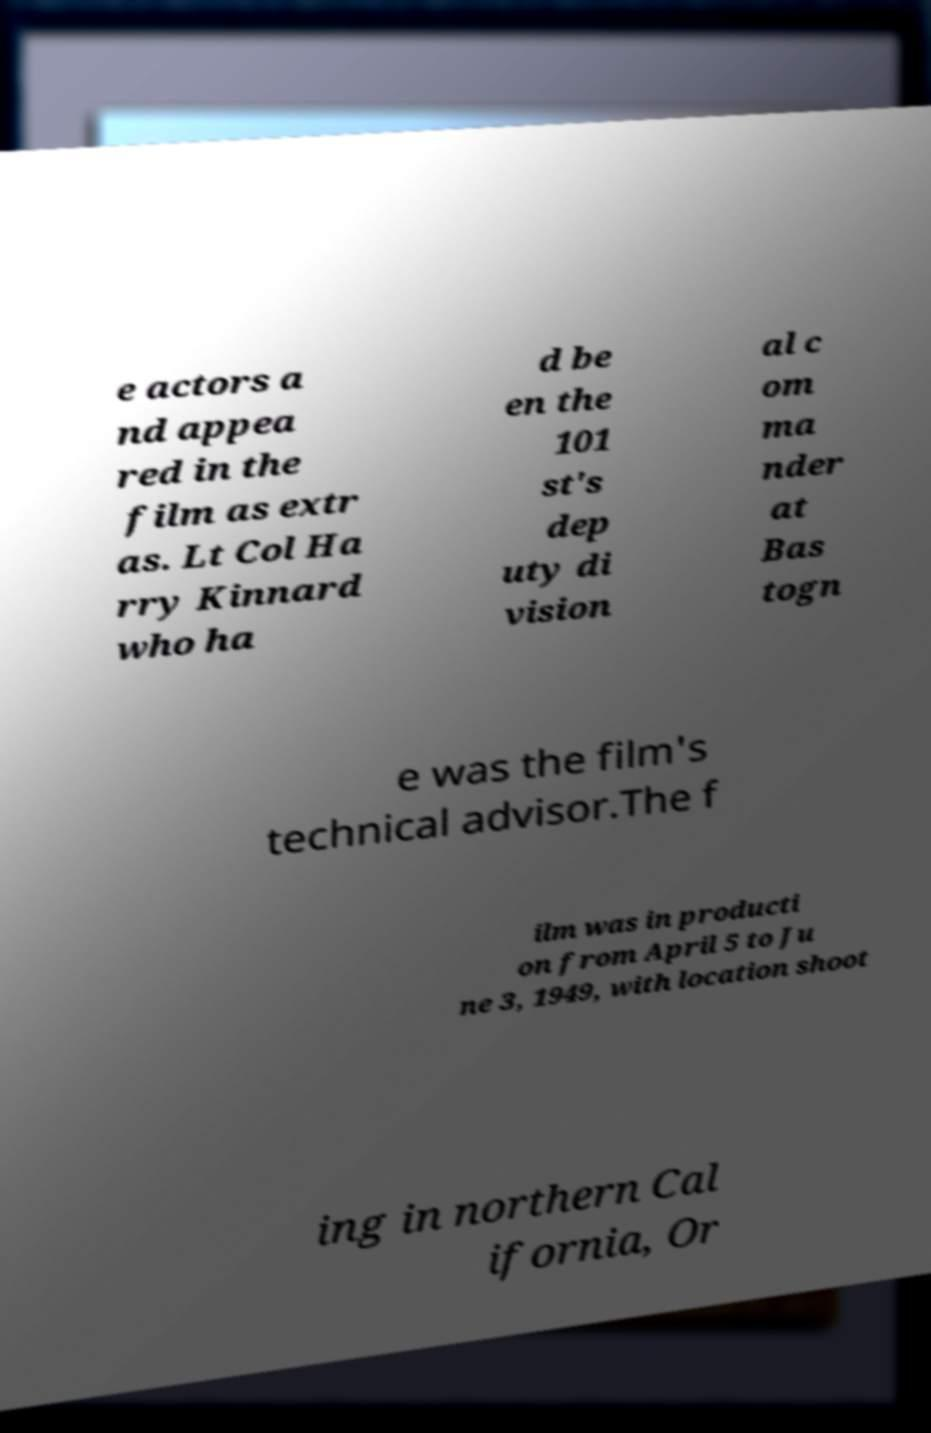Could you assist in decoding the text presented in this image and type it out clearly? e actors a nd appea red in the film as extr as. Lt Col Ha rry Kinnard who ha d be en the 101 st's dep uty di vision al c om ma nder at Bas togn e was the film's technical advisor.The f ilm was in producti on from April 5 to Ju ne 3, 1949, with location shoot ing in northern Cal ifornia, Or 